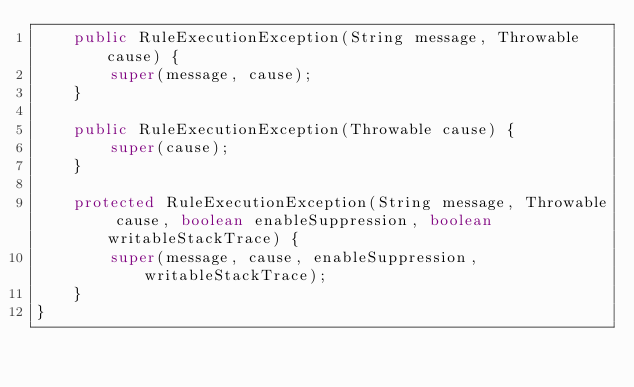Convert code to text. <code><loc_0><loc_0><loc_500><loc_500><_Java_>    public RuleExecutionException(String message, Throwable cause) {
        super(message, cause);
    }

    public RuleExecutionException(Throwable cause) {
        super(cause);
    }

    protected RuleExecutionException(String message, Throwable cause, boolean enableSuppression, boolean writableStackTrace) {
        super(message, cause, enableSuppression, writableStackTrace);
    }
}
</code> 